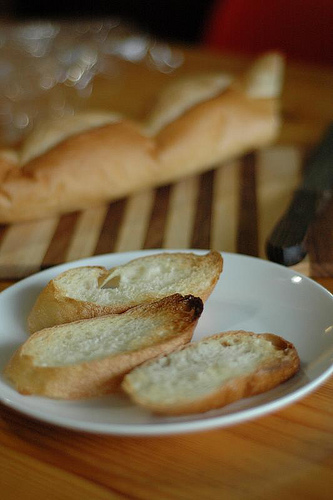<image>
Is there a bread under the plate? No. The bread is not positioned under the plate. The vertical relationship between these objects is different. Is the bread on the table? No. The bread is not positioned on the table. They may be near each other, but the bread is not supported by or resting on top of the table. 